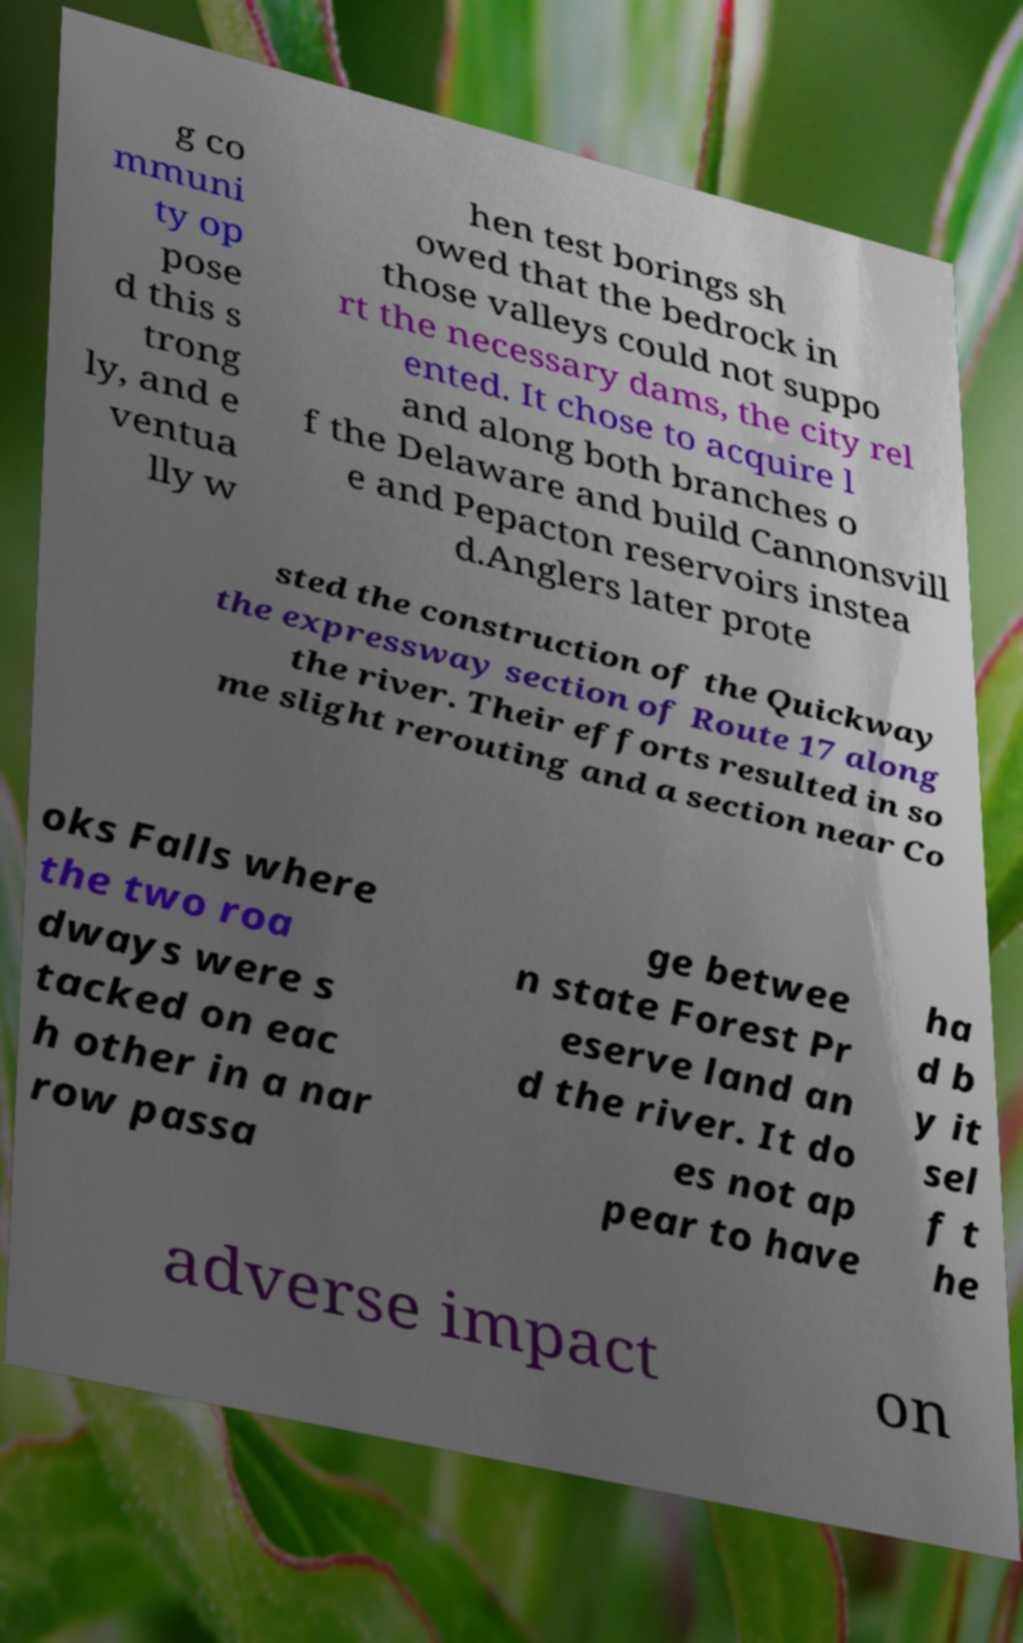Please read and relay the text visible in this image. What does it say? g co mmuni ty op pose d this s trong ly, and e ventua lly w hen test borings sh owed that the bedrock in those valleys could not suppo rt the necessary dams, the city rel ented. It chose to acquire l and along both branches o f the Delaware and build Cannonsvill e and Pepacton reservoirs instea d.Anglers later prote sted the construction of the Quickway the expressway section of Route 17 along the river. Their efforts resulted in so me slight rerouting and a section near Co oks Falls where the two roa dways were s tacked on eac h other in a nar row passa ge betwee n state Forest Pr eserve land an d the river. It do es not ap pear to have ha d b y it sel f t he adverse impact on 